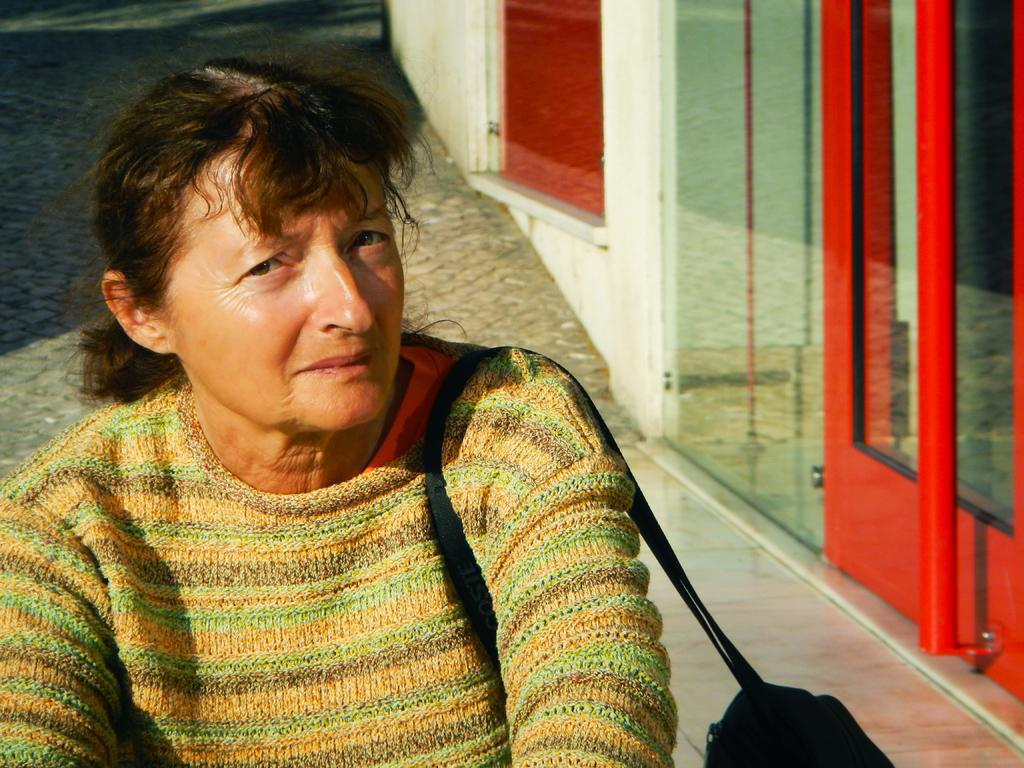What is the main subject of the image? The main subject of the image is a woman. What is the woman carrying in the image? The woman is carrying a bag. Can you describe what is visible in the background of the image? There are objects visible in the background of the image. What type of bone is visible in the image? There is no bone present in the image. What stage of development is the woman in the image? The provided facts do not give us enough information to determine the stage of development of the woman in the image. 